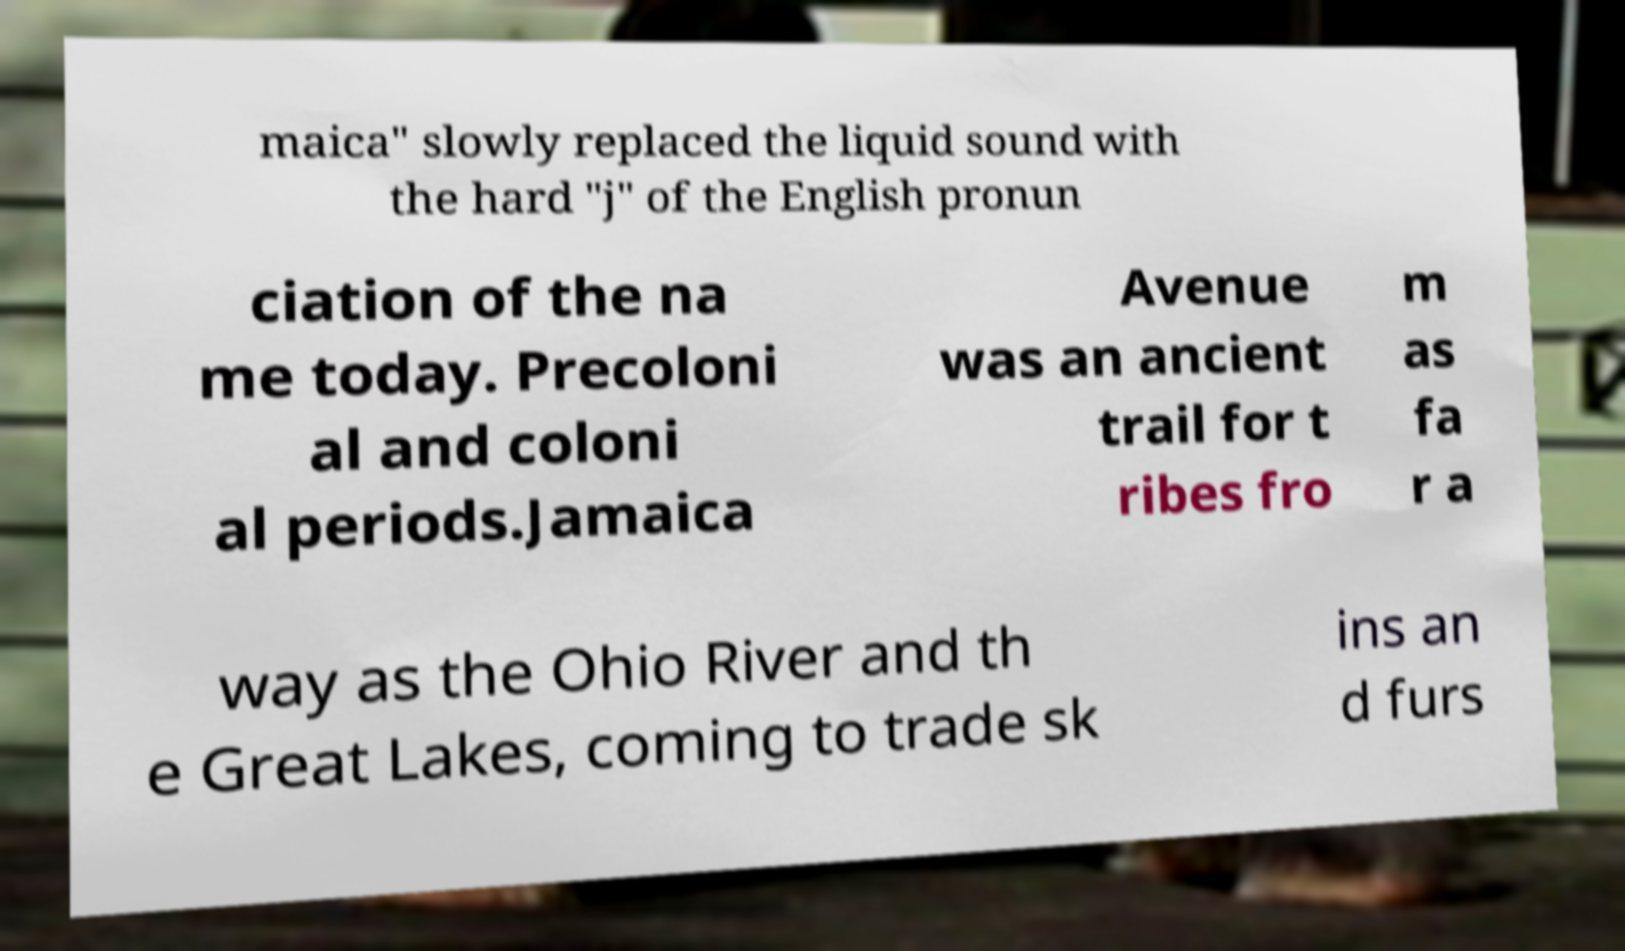There's text embedded in this image that I need extracted. Can you transcribe it verbatim? maica" slowly replaced the liquid sound with the hard "j" of the English pronun ciation of the na me today. Precoloni al and coloni al periods.Jamaica Avenue was an ancient trail for t ribes fro m as fa r a way as the Ohio River and th e Great Lakes, coming to trade sk ins an d furs 